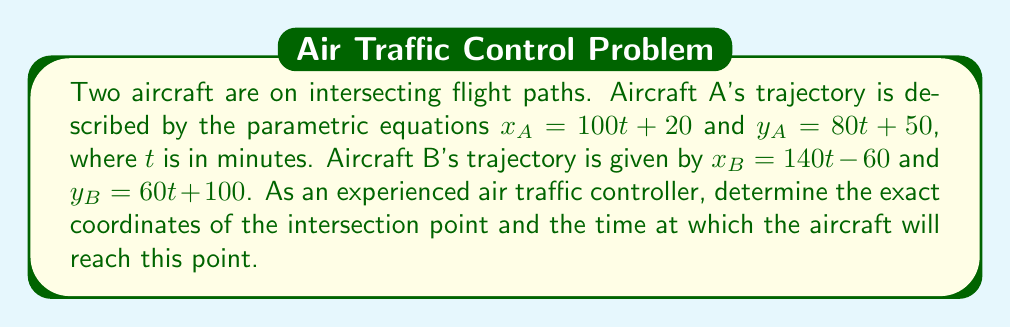Teach me how to tackle this problem. To solve this problem, we need to find the point where the two trajectories intersect. This occurs when both the x and y coordinates of the two aircraft are equal.

Step 1: Set up equations for the intersection point
$x_A = x_B$ and $y_A = y_B$

Step 2: Substitute the given parametric equations
$100t_A + 20 = 140t_B - 60$
$80t_A + 50 = 60t_B + 100$

Step 3: Solve for $t_A$ and $t_B$
From the first equation:
$100t_A - 140t_B = -80$

From the second equation:
$80t_A - 60t_B = 50$

Multiply the second equation by 5/4 to make the coefficients of $t_A$ equal:
$100t_A - 75t_B = 62.5$

Subtract this from the first equation:
$65t_B = 142.5$
$t_B = \frac{142.5}{65} \approx 2.1923$ minutes

Substitute this value back into either of the original equations to find $t_A$:
$100t_A + 20 = 140(2.1923) - 60$
$100t_A = 246.92$
$t_A = 2.4692$ minutes

Step 4: Calculate the intersection point
Using either aircraft's equations with their respective $t$ value:

For Aircraft A:
$x = 100(2.4692) + 20 = 266.92$
$y = 80(2.4692) + 50 = 247.54$

Step 5: Verify using Aircraft B's equations
$x = 140(2.1923) - 60 = 266.92$
$y = 60(2.1923) + 100 = 247.54$

The results match, confirming our solution.
Answer: The aircraft trajectories intersect at the point (266.92, 247.54). Aircraft A will reach this point after 2.4692 minutes, while Aircraft B will reach it after 2.1923 minutes. 